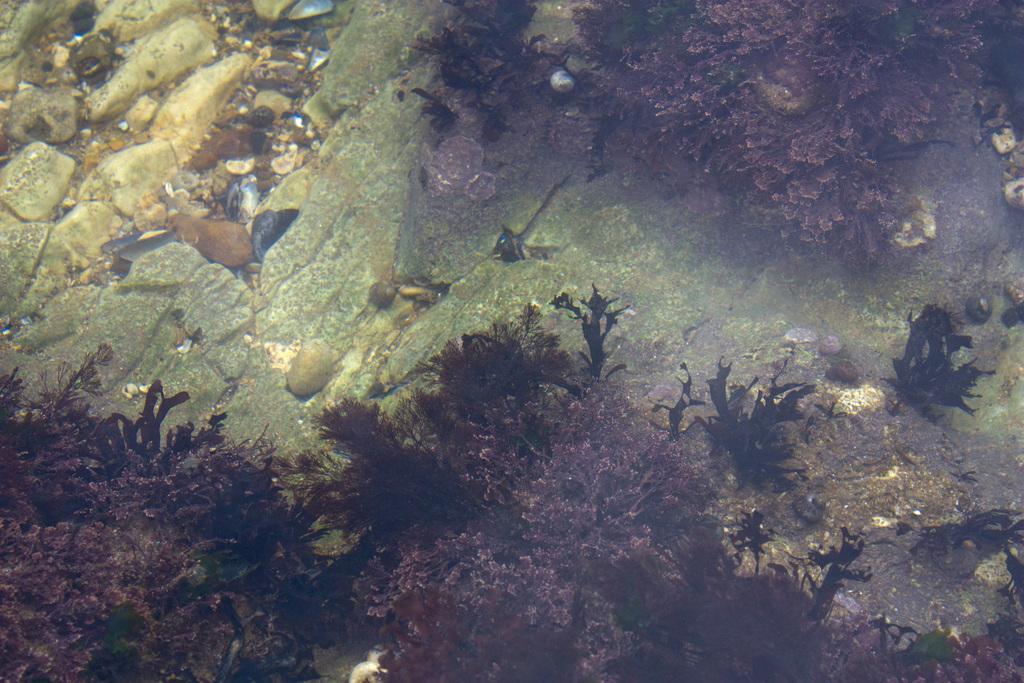Could you give a brief overview of what you see in this image? In this picture we can see plants, stones on the rock surface under the water. 